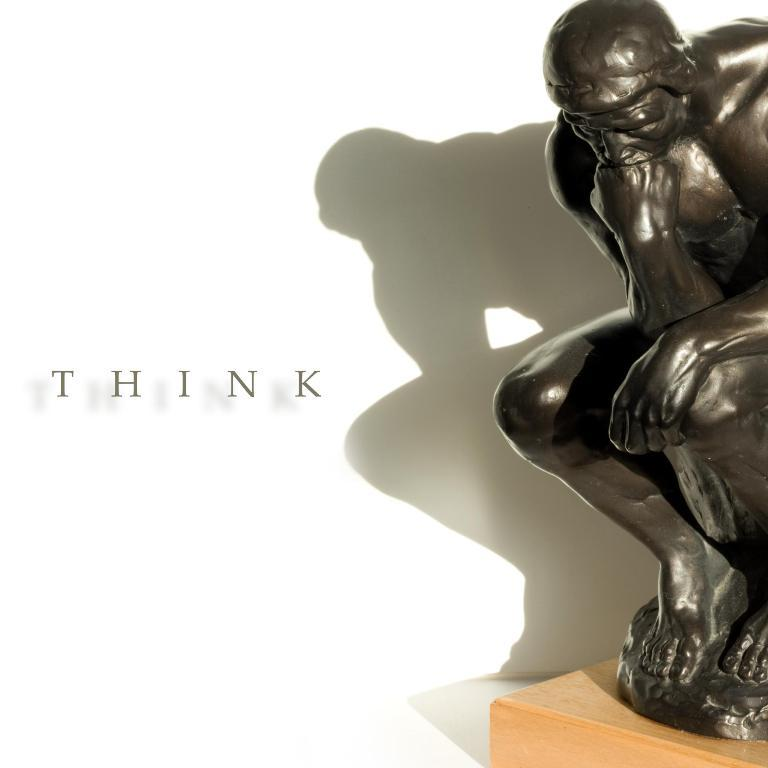What is the main subject on the table in the image? There is a statue of a man on the table. What can be seen on the left side of the picture? There is text on the left side of the picture. What color is the background of the image? The background of the image is white. What is the range of the earth's atmosphere in the image? There is no reference to the earth's atmosphere or any range in the image; it features a statue of a man on a table with text on the left side and a white background. 